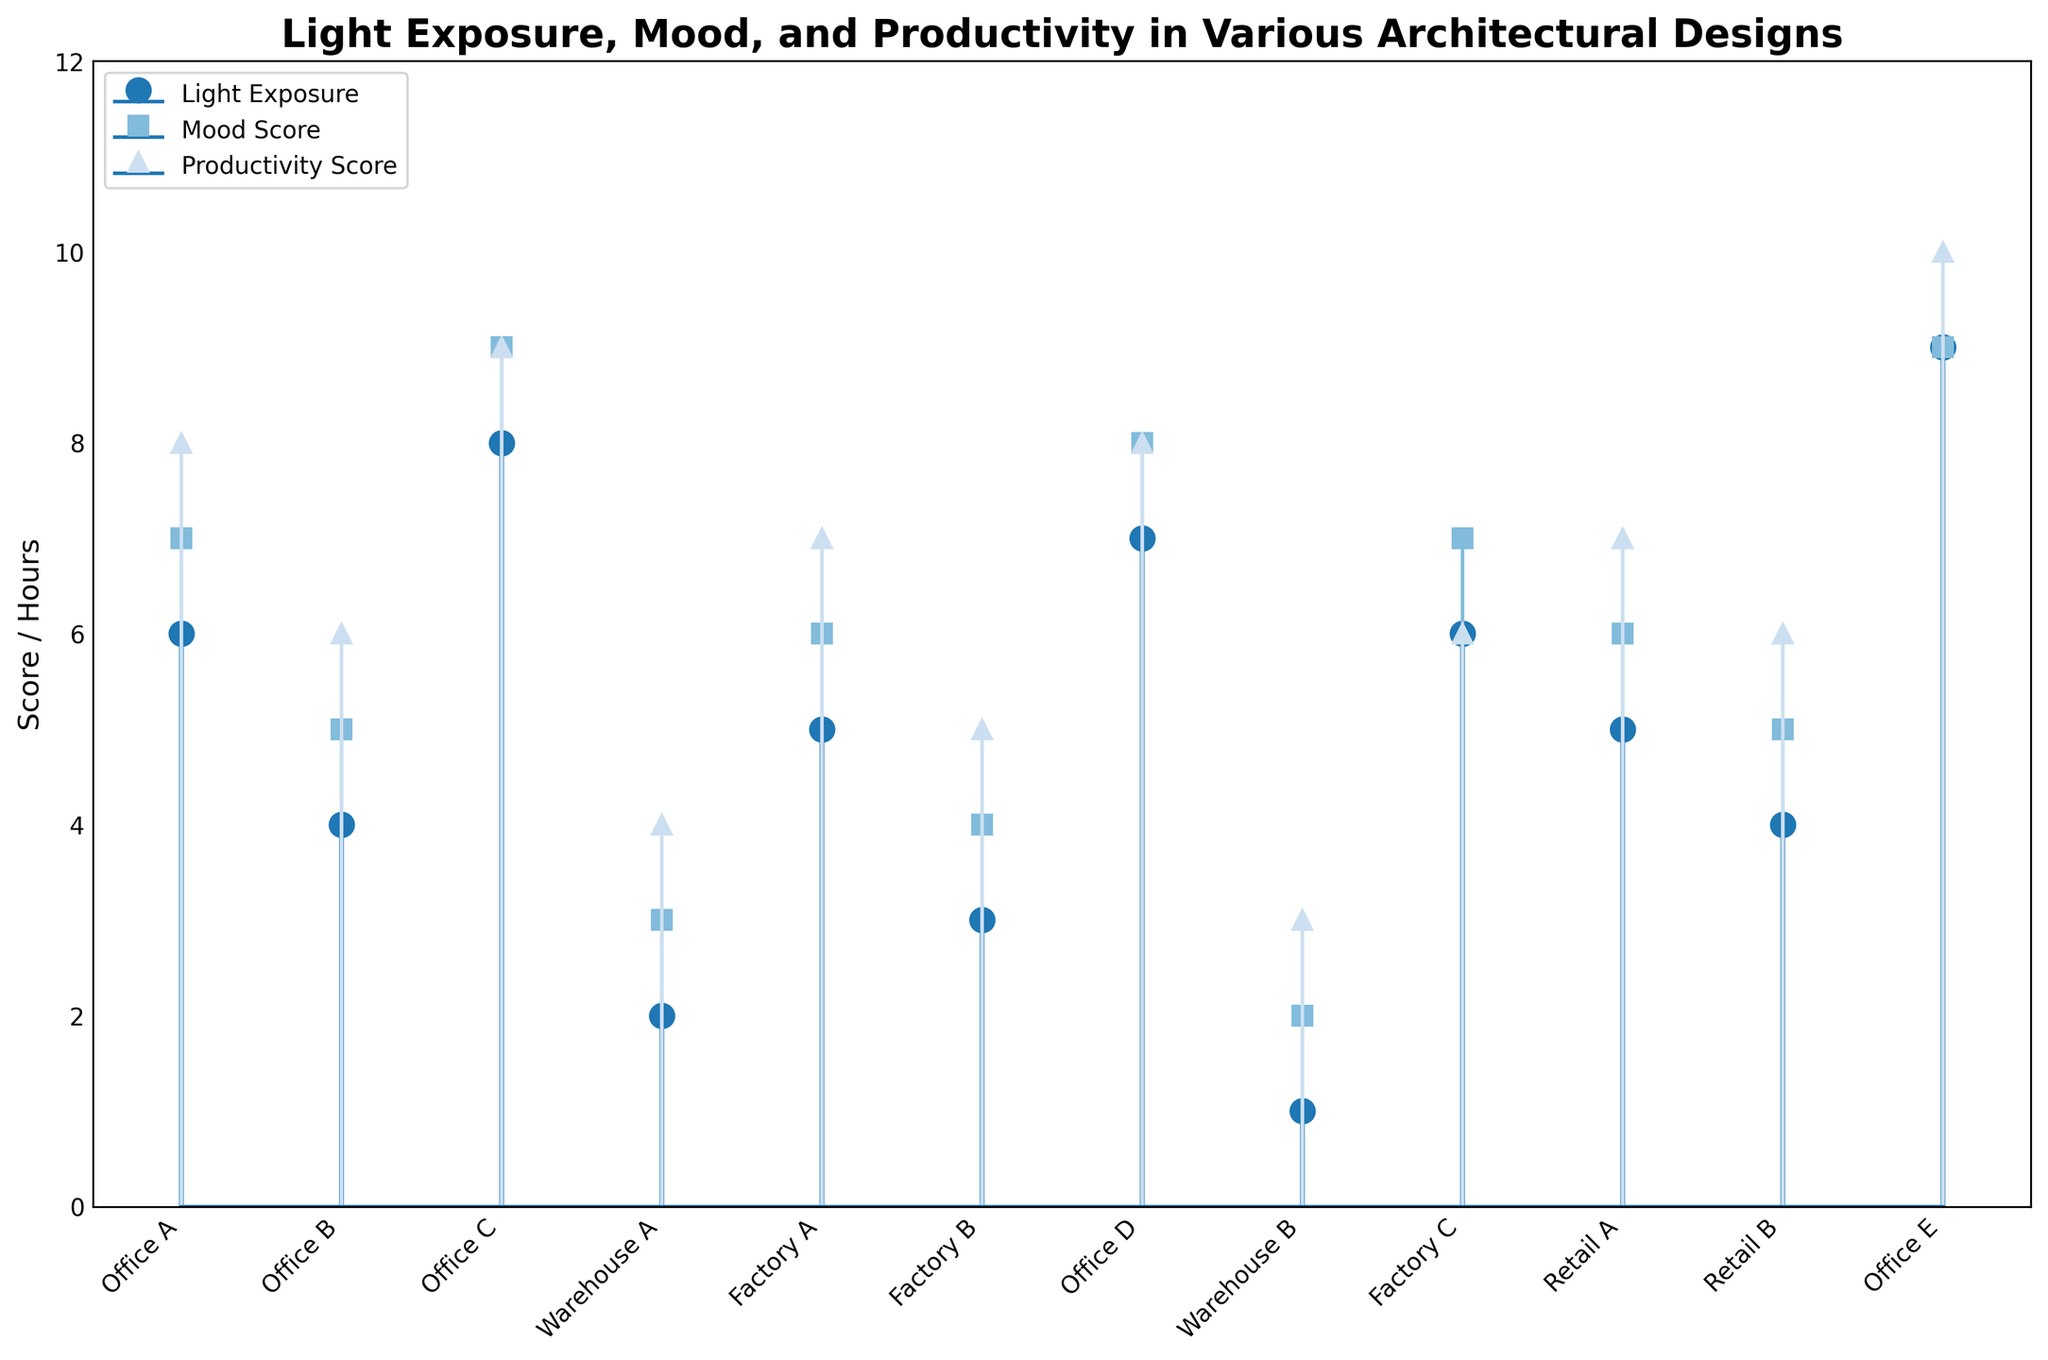What's the title of the figure? The title of the figure is prominently displayed at the top of the plot. It gives insight into the main subject of the figure.
Answer: Light Exposure, Mood, and Productivity in Various Architectural Designs What is the range of the y-axis? The y-axis shows the scores and hours. By looking at the figure, we can see the lowest value starts at 0 and the highest value reaches 12.
Answer: 0 to 12 Which building has the highest light exposure? Looking at the stem plot, the building with the tallest stem in the light exposure category will have the highest light exposure. In this case, that is noticeable by spotting the building with the highest point on the plot for light exposure.
Answer: Office E How many buildings have mood scores of 9? By counting the number of stems reaching the 9-mark in the Mood Score series, we can determine the number of buildings with a mood score of 9.
Answer: 2 What is the difference in light exposure between Warehouse B and Office E? Locate the stems for both Warehouse B and Office E in the light exposure series and find their corresponding values. Calculate the difference between Office E's light exposure (which is 9 hours) and Warehouse B's (which is 1 hour).
Answer: 8 hours Which building has the equal mood and productivity scores? Look for buildings where the mood and productivity stems align at the same height on the y-axis.
Answer: Office A, Office D, Office E What is the average productivity score of all buildings? Add all the productivity scores and divide by the number of buildings. The productivity scores are 8, 6, 9, 4, 7, 5, 8, 3, 6, 7, 6, 10. The sum is 79. Divided by 12 buildings, the average is 79/12.
Answer: 6.58 Is there any building where light exposure is less than productivity? Compare the height of the stems for light exposure and productivity for each building.
Answer: No 